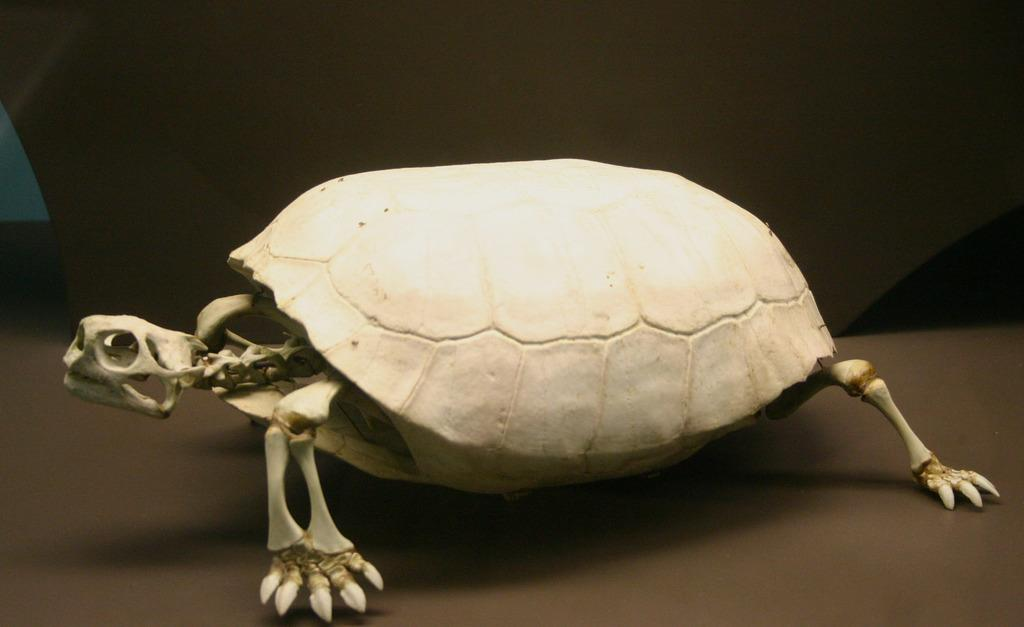What is the main subject in the foreground of the image? There is a skeleton of a tortoise in the foreground of the image. What is the color of the floor in the image? The floor in the image is brown in color. Where is the lumber being stored in the image? There is no lumber present in the image. What type of appliance can be seen plugged into the wall in the image? There are no appliances visible in the image. 